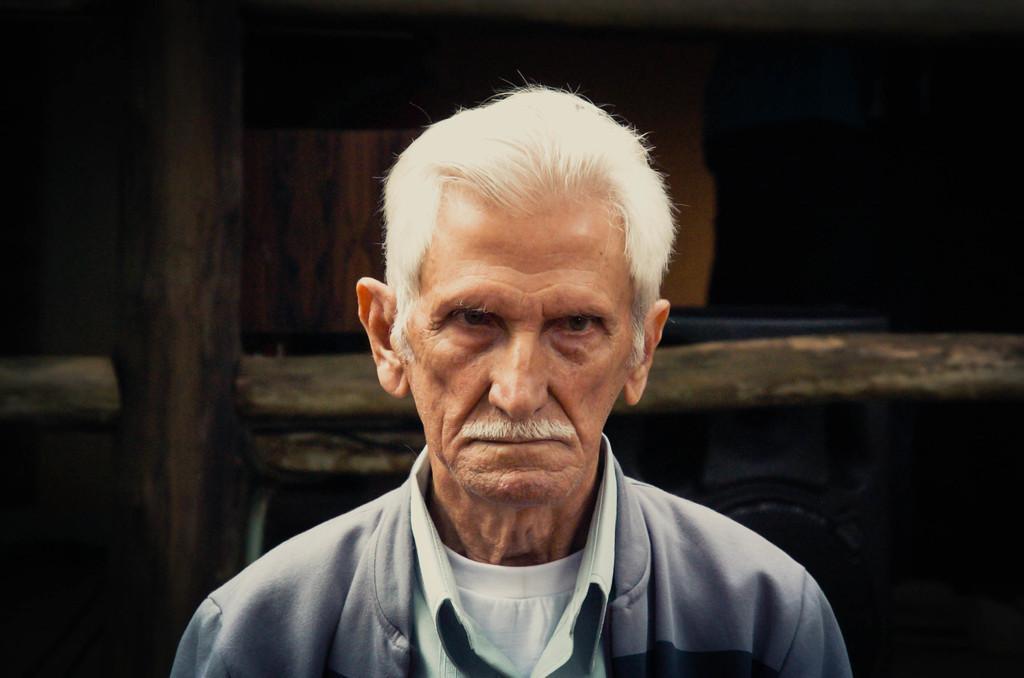Could you give a brief overview of what you see in this image? In this image we can see a person. There are few objects behind a person in the image. 